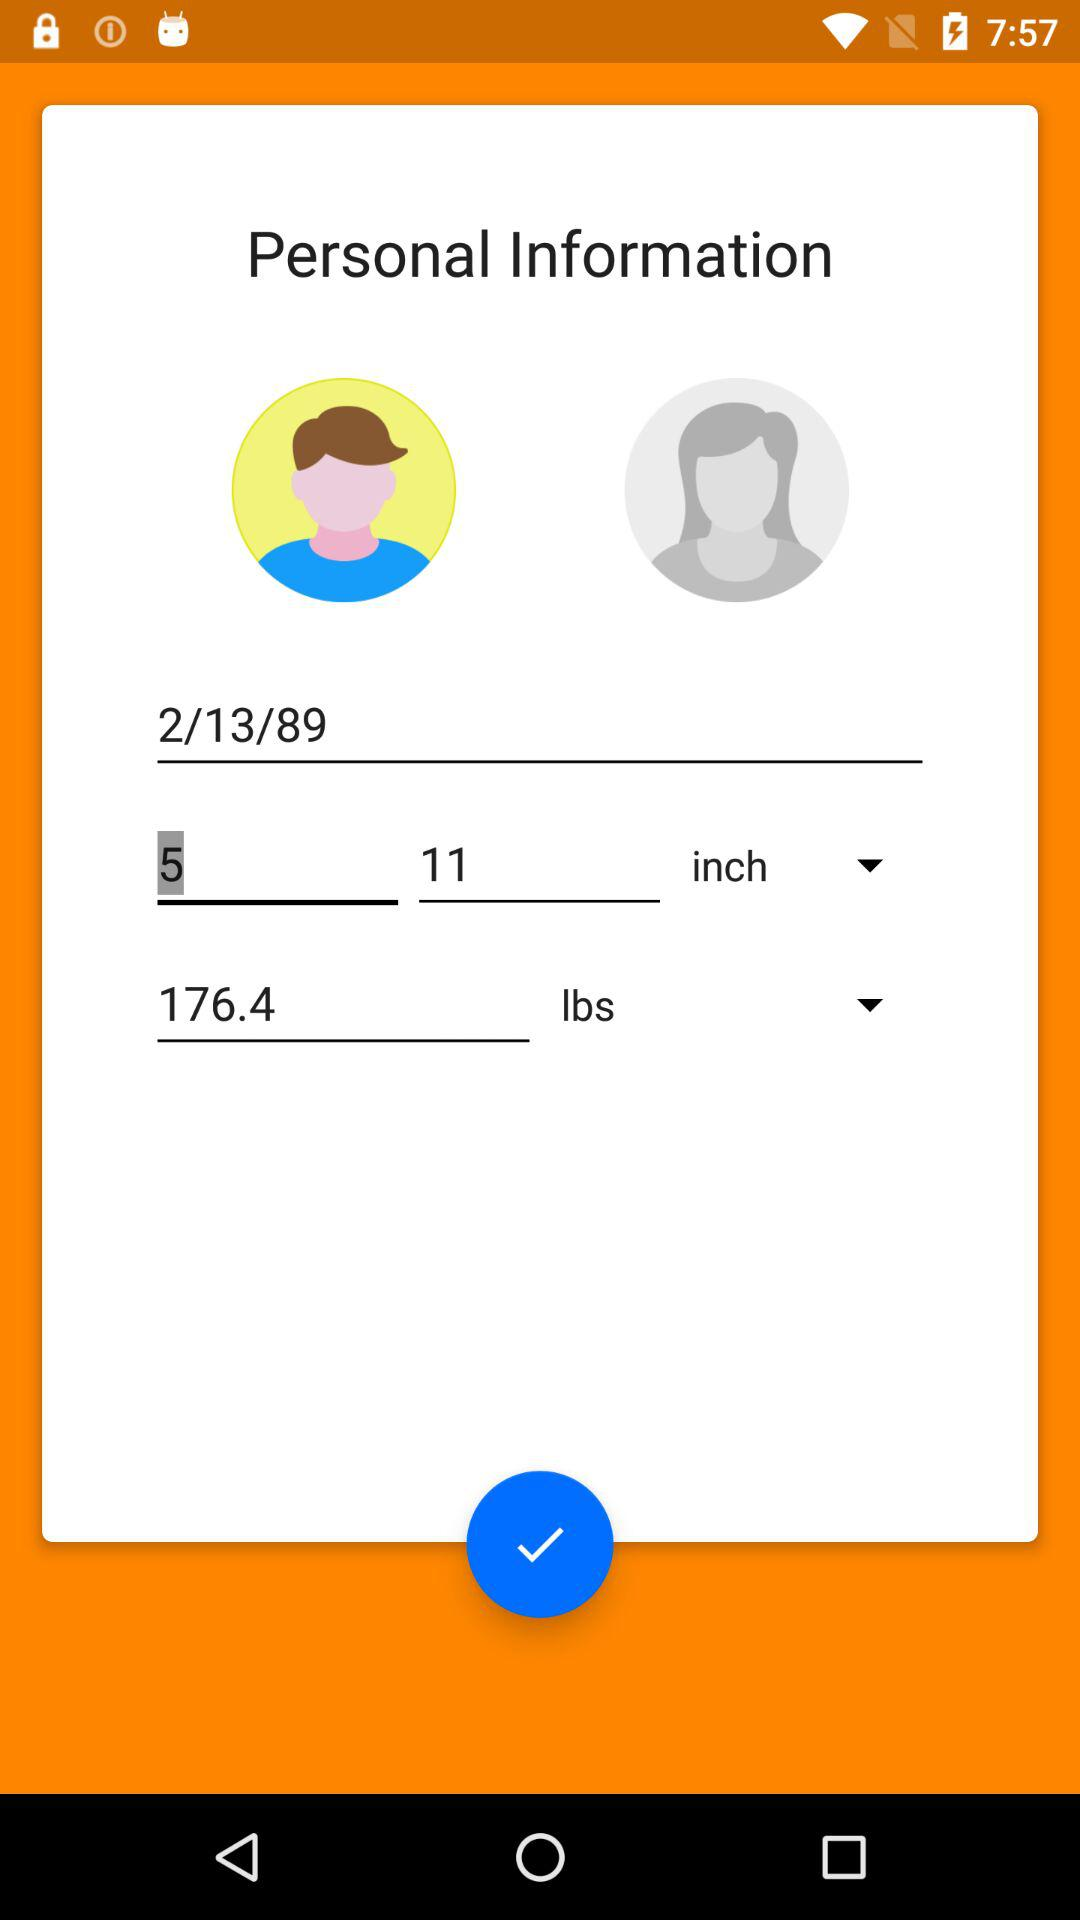How much more does the person with the weight of 176.4 lbs weigh than the person with the weight of 110 lbs?
Answer the question using a single word or phrase. 66.4 